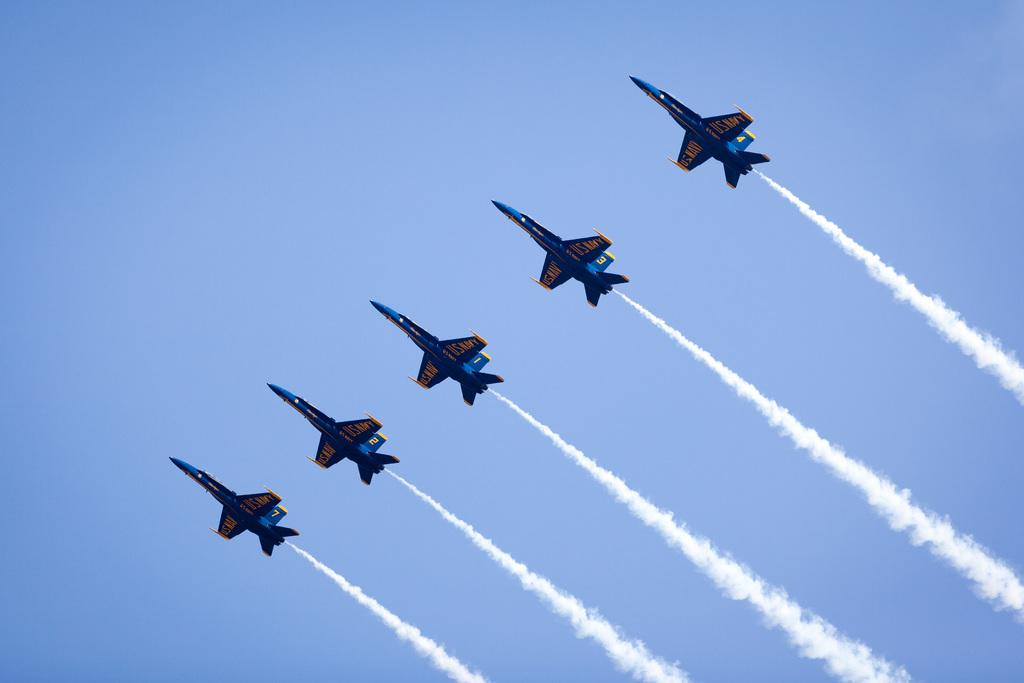What type of vehicles are in the image? There are jet planes in the image. What are the jet planes doing in the image? The jet planes are releasing smoke. What colors are the jet planes? The jet planes are blue and yellow in color. What is the color of the sky in the image? The sky is blue in the image. Can you see a window in the image? There is no window present in the image; it features jet planes releasing smoke against a blue sky. 